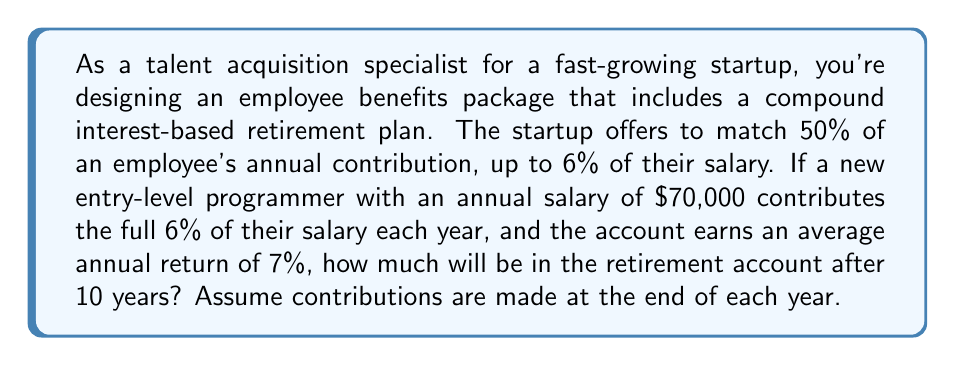Solve this math problem. Let's break this down step-by-step:

1. Calculate the annual contribution:
   Employee contribution: $70,000 * 6% = $4,200
   Employer match: 50% of $4,200 = $2,100
   Total annual contribution: $4,200 + $2,100 = $6,300

2. We'll use the compound interest formula for end-of-year contributions:
   $$A = P \cdot \frac{(1 + r)^n - 1}{r} \cdot (1 + r)$$
   Where:
   $A$ = final amount
   $P$ = annual contribution
   $r$ = annual interest rate
   $n$ = number of years

3. Plug in the values:
   $P = 6,300$
   $r = 0.07$ (7% as a decimal)
   $n = 10$

4. Calculate:
   $$A = 6,300 \cdot \frac{(1 + 0.07)^{10} - 1}{0.07} \cdot (1 + 0.07)$$

5. Solve:
   $$A = 6,300 \cdot \frac{1.9672 - 1}{0.07} \cdot 1.07$$
   $$A = 6,300 \cdot 13.8164 \cdot 1.07$$
   $$A = 93,097.25$$

Therefore, after 10 years, the retirement account will have $93,097.25.
Answer: $93,097.25 